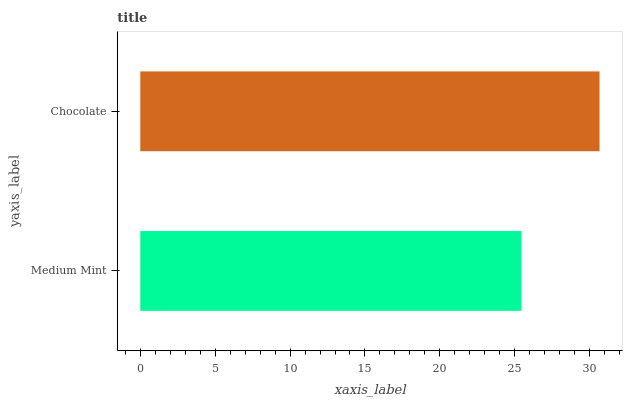Is Medium Mint the minimum?
Answer yes or no. Yes. Is Chocolate the maximum?
Answer yes or no. Yes. Is Chocolate the minimum?
Answer yes or no. No. Is Chocolate greater than Medium Mint?
Answer yes or no. Yes. Is Medium Mint less than Chocolate?
Answer yes or no. Yes. Is Medium Mint greater than Chocolate?
Answer yes or no. No. Is Chocolate less than Medium Mint?
Answer yes or no. No. Is Chocolate the high median?
Answer yes or no. Yes. Is Medium Mint the low median?
Answer yes or no. Yes. Is Medium Mint the high median?
Answer yes or no. No. Is Chocolate the low median?
Answer yes or no. No. 